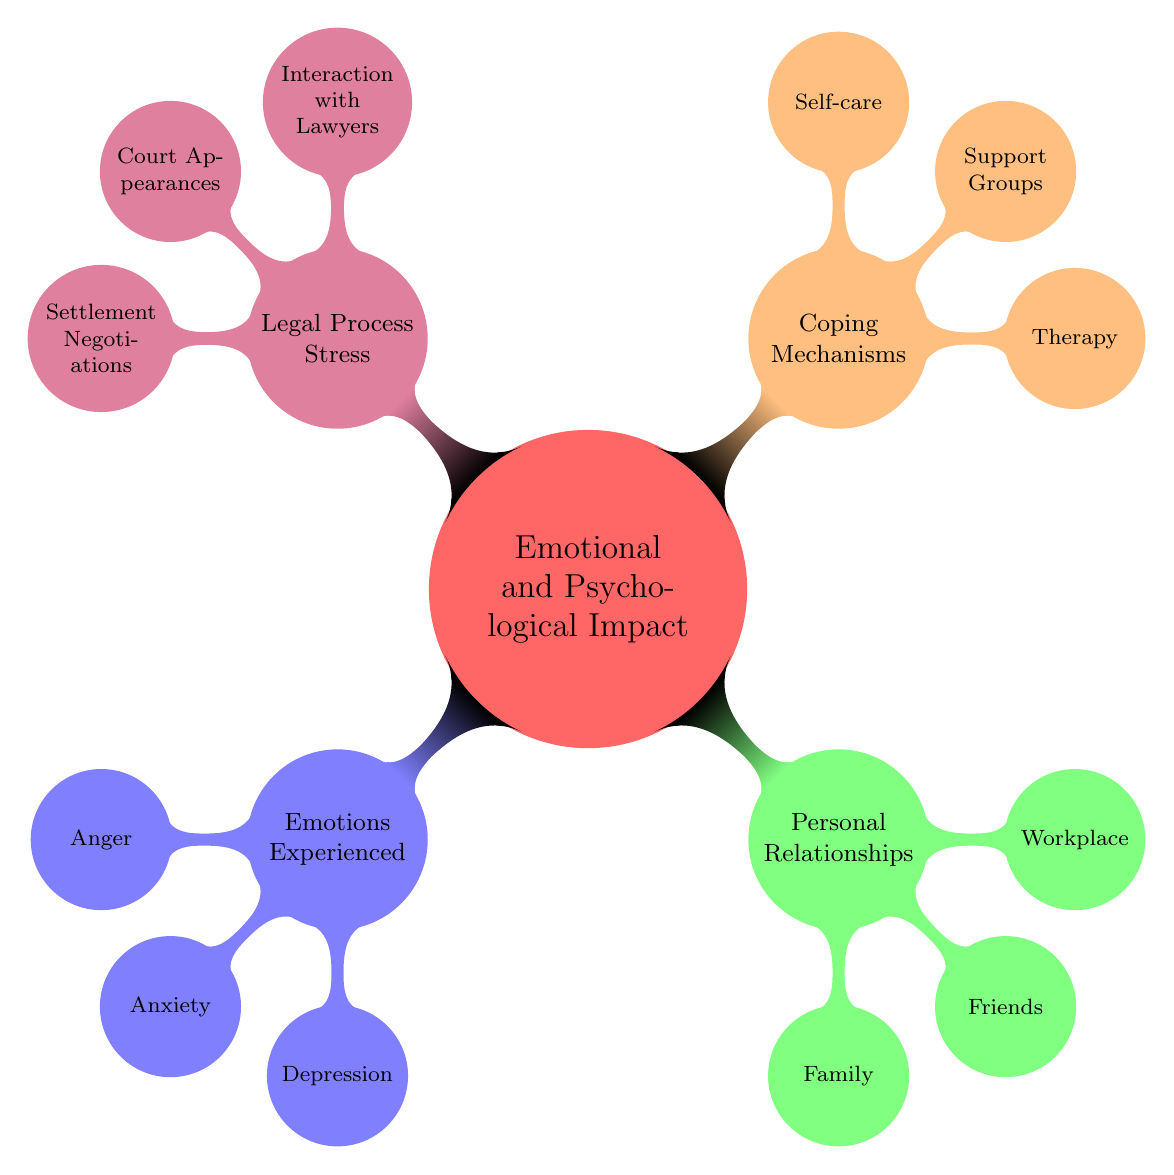What are the three main categories of emotional and psychological impact? The diagram displays four main categories under "Emotional and Psychological Impact": Emotions Experienced, Personal Relationships, Coping Mechanisms, and Legal Process Stress.
Answer: Emotions Experienced, Personal Relationships, Coping Mechanisms, Legal Process Stress How many emotions are listed under the "Emotions Experienced" node? According to the diagram, there are three emotions detailed under "Emotions Experienced": Anger, Anxiety, and Depression.
Answer: 3 What type of support is offered by family members according to the diagram? The "Personal Relationships" section specifically describes the support offered by family as "Emotional, logistical." This indicates the nature of the support family provides.
Answer: Emotional, logistical What is one coping mechanism mentioned in the mind map? The "Coping Mechanisms" section lists three types of coping strategies. One such mechanism is "Therapy," which is highlighted as a way to deal with emotional challenges.
Answer: Therapy Which node discusses the emotional toll of legal processes? The "Legal Process Stress" node explains various aspects of legal proceedings and specifically mentions the "Emotional Toll" as a component under "Interaction with Lawyers," focusing on the emotional strain during legal proceedings.
Answer: Interaction with Lawyers What are two benefits of support groups according to the diagram? The diagram under the "Coping Mechanisms" section states two benefits of support groups: "Shared experiences" and "emotional validation." Therefore, both are highlighted as important advantages of participating in such groups.
Answer: Shared experiences, emotional validation What causes anxiety as per the emotional impacts described? The diagram lists "Uncertainty about future, medical bills" as the source of anxiety. It connects the emotional state to the external factors influencing it, highlighting why a person may feel anxious.
Answer: Uncertainty about future, medical bills What type of therapy is mentioned and provides coping strategies? Under the "Coping Mechanisms," the type of therapy explicitly mentioned is "Cognitive Behavioral Therapy," which is recognized for providing strategies to help cope with emotional challenges.
Answer: Cognitive Behavioral Therapy 